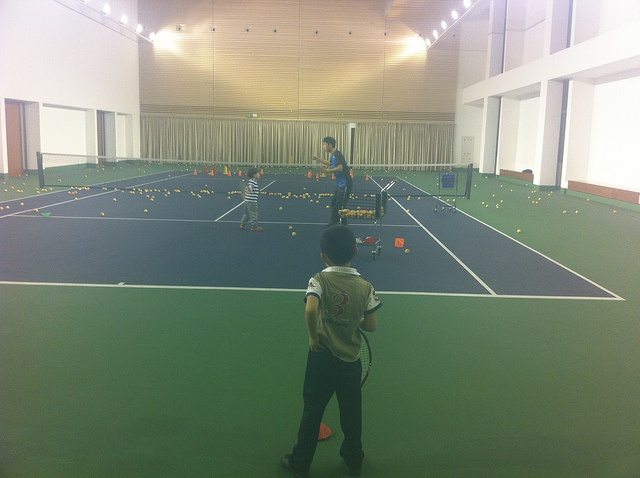Describe the objects in this image and their specific colors. I can see sports ball in lavender, gray, and darkgray tones, people in lavender, black, darkgreen, and teal tones, people in lavender, gray, and purple tones, people in lavender, gray, darkgray, and purple tones, and tennis racket in lavender, darkgreen, and black tones in this image. 